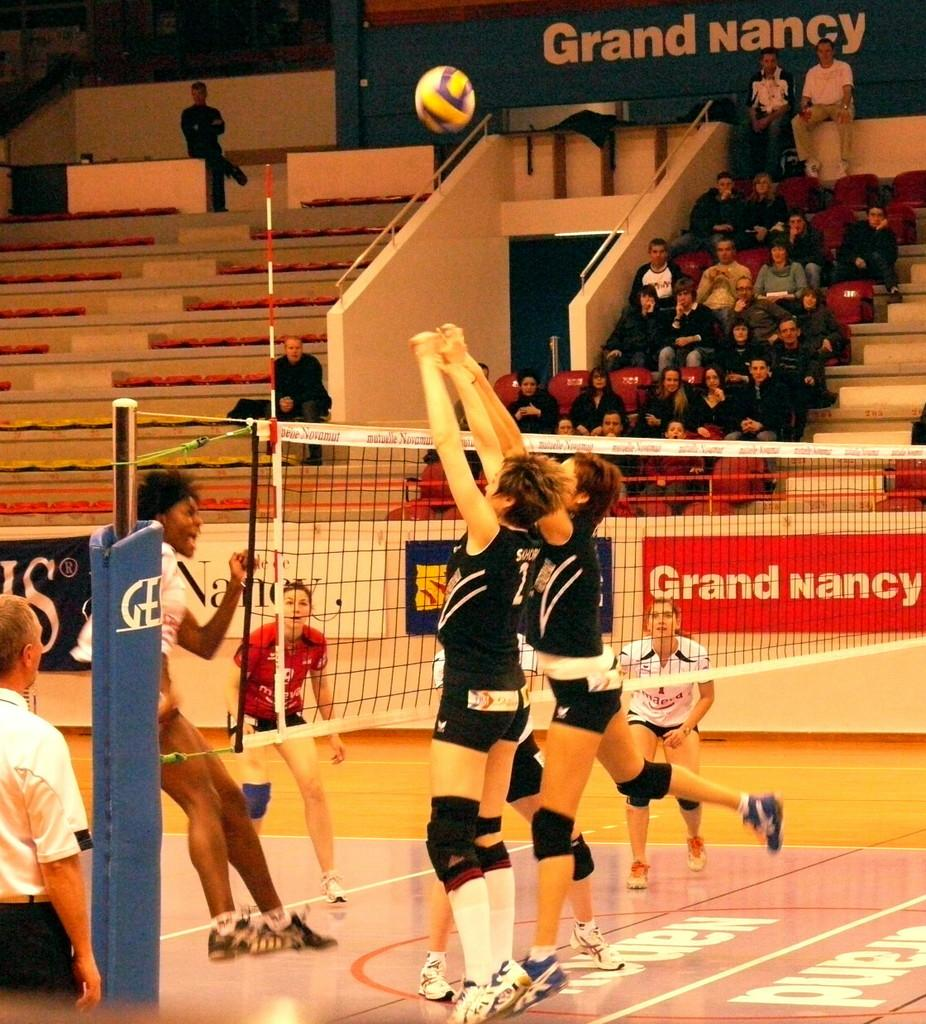<image>
Relay a brief, clear account of the picture shown. Women playing volleyball with a giant red sign that says Grand Nancy. 